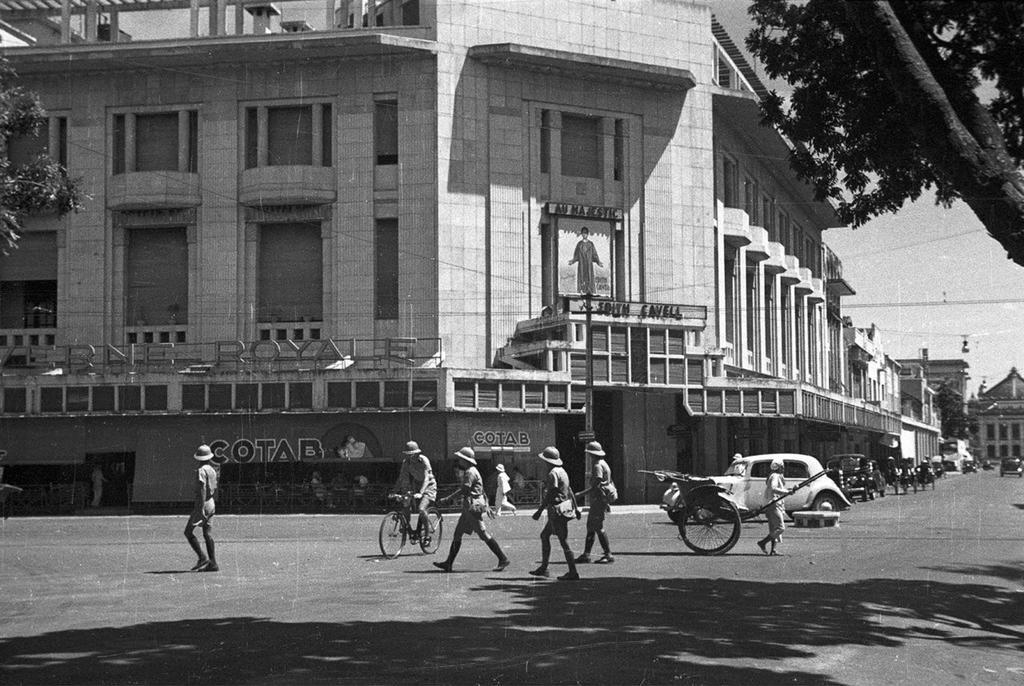Could you give a brief overview of what you see in this image? At the bottom of this image, there are persons and vehicles on the road. On the left side, there is a tree. On the right side, there is a tree. In the background, there are buildings, cables and there are clouds in the sky. 